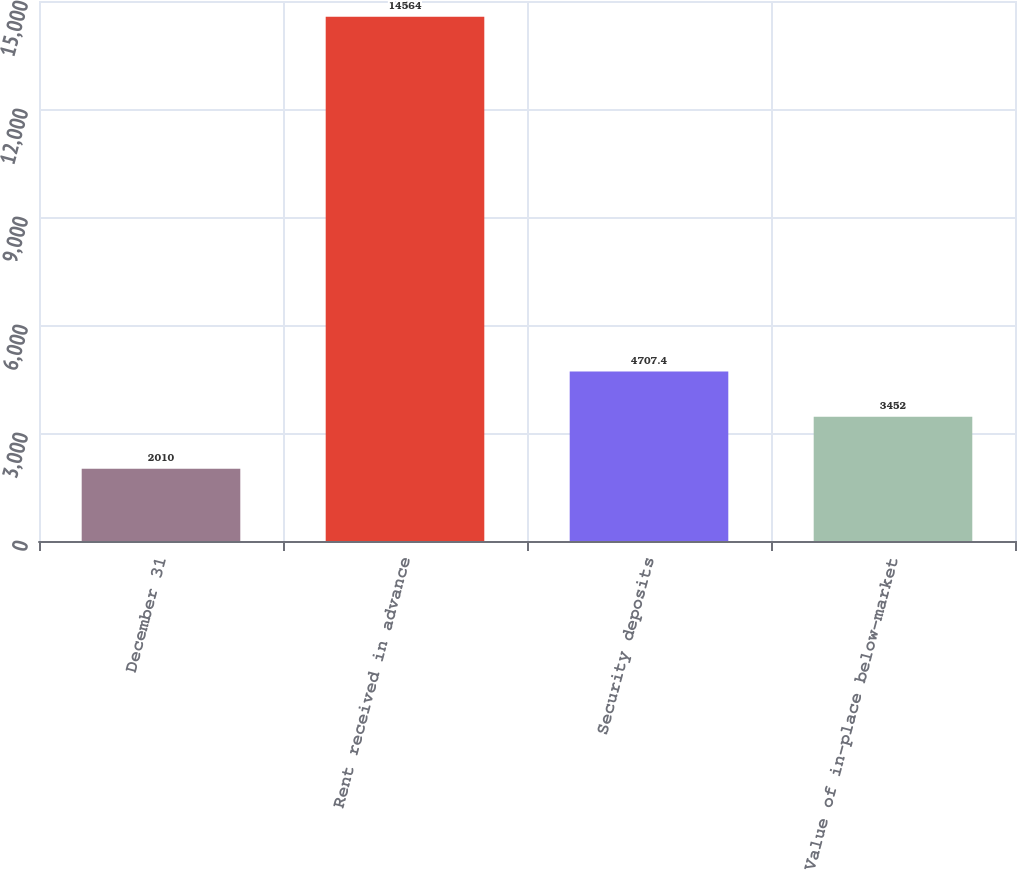Convert chart to OTSL. <chart><loc_0><loc_0><loc_500><loc_500><bar_chart><fcel>December 31<fcel>Rent received in advance<fcel>Security deposits<fcel>Value of in-place below-market<nl><fcel>2010<fcel>14564<fcel>4707.4<fcel>3452<nl></chart> 